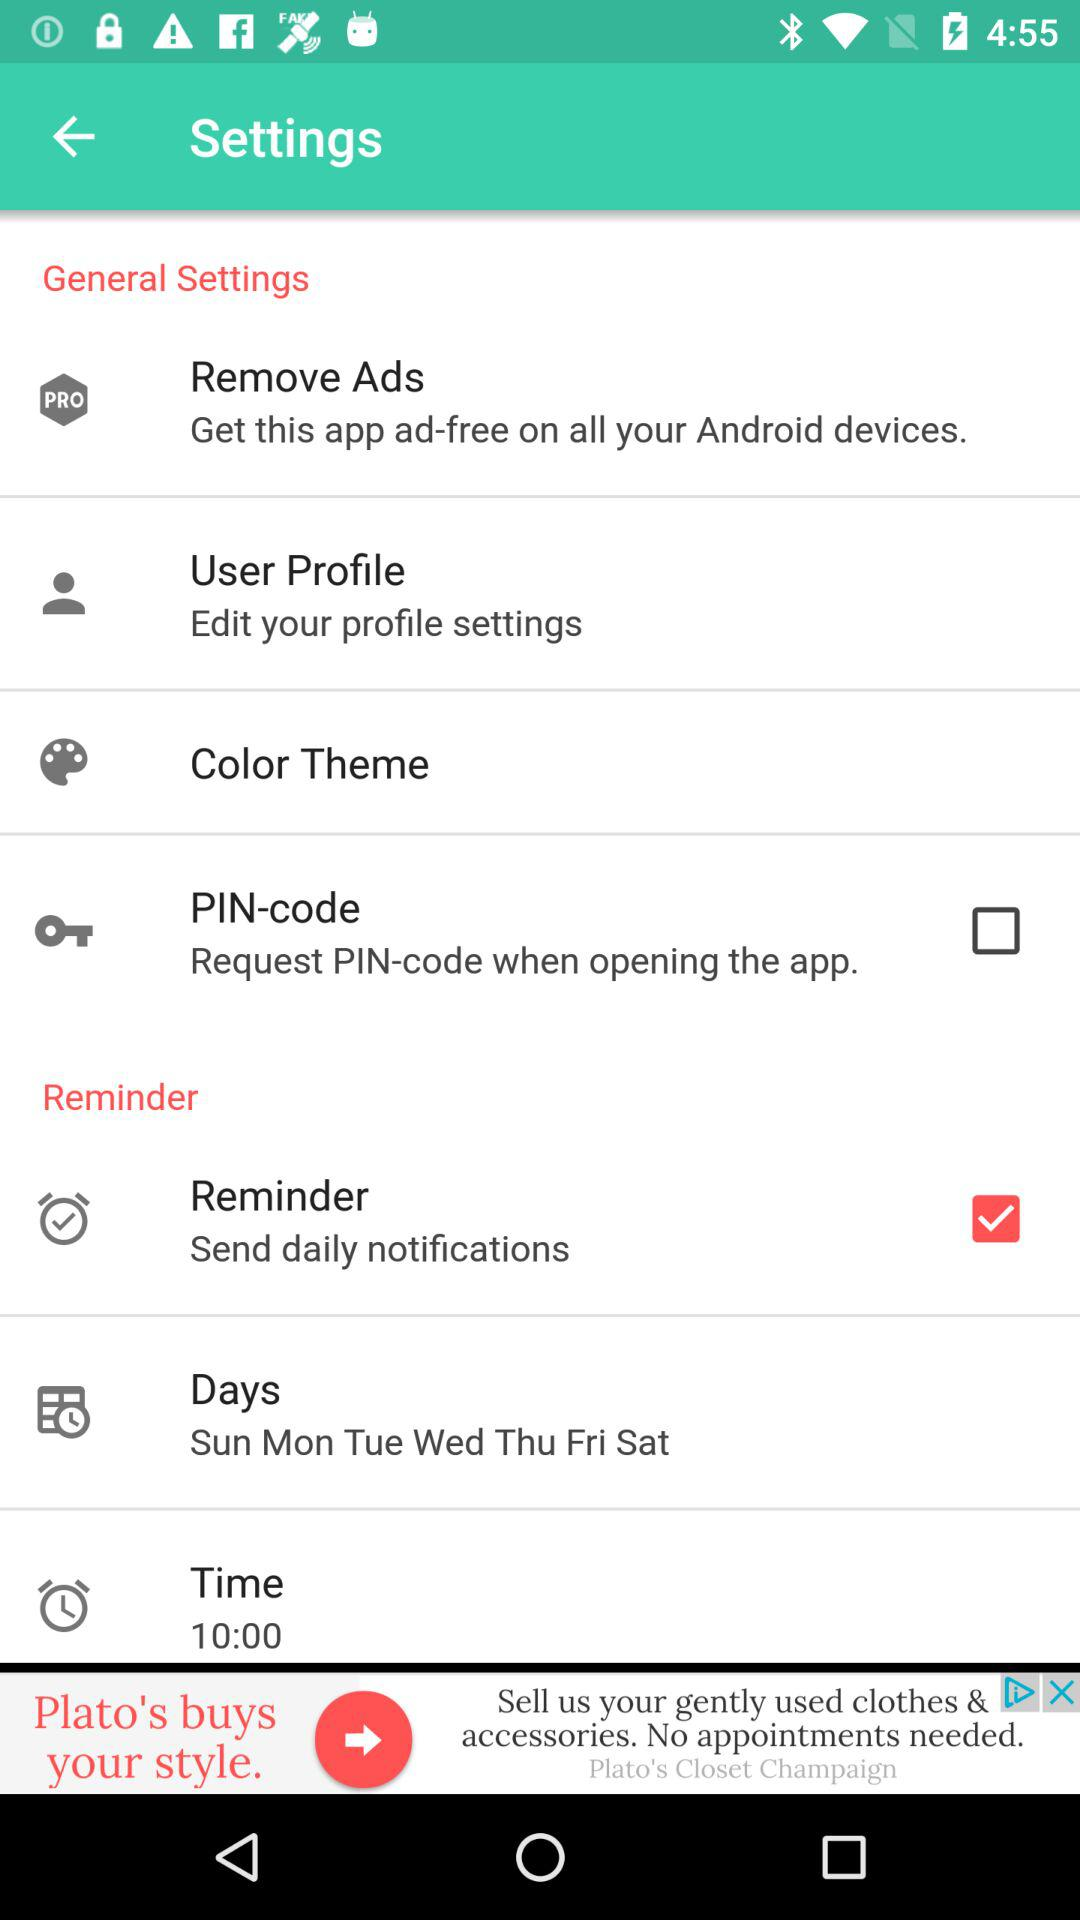What is the current status of the PIN-code? The current status of the PIN-code is off. 